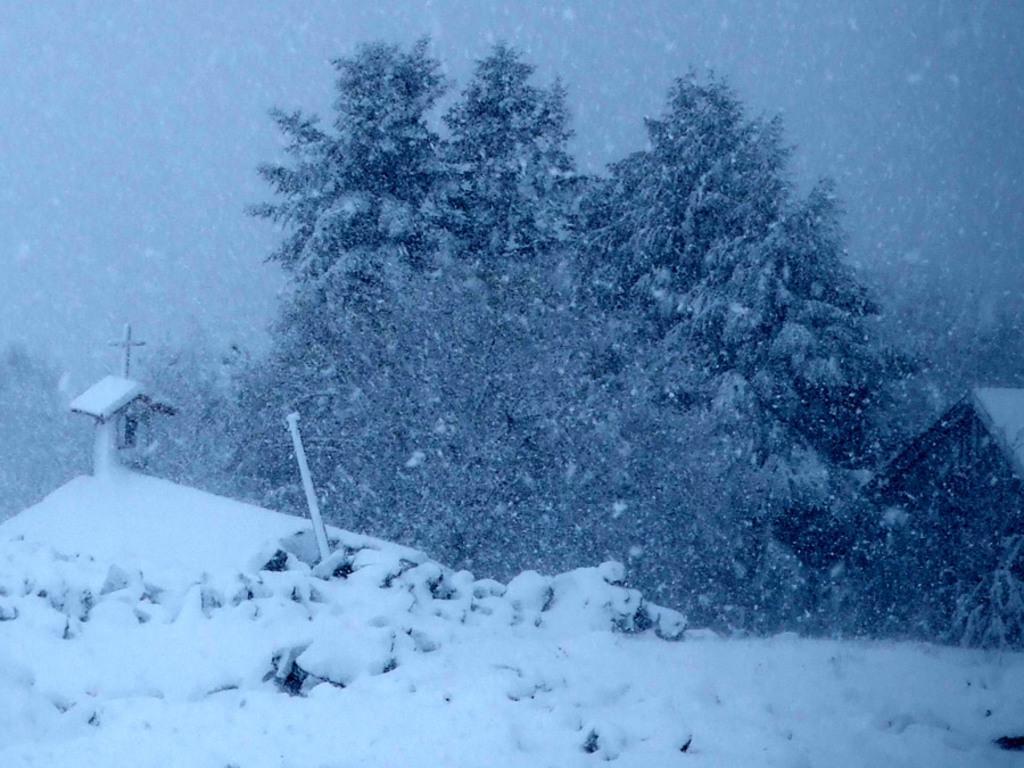How would you summarize this image in a sentence or two? In this picture we can see a house, pole, holly cross symbol, trees, snow and an object. 